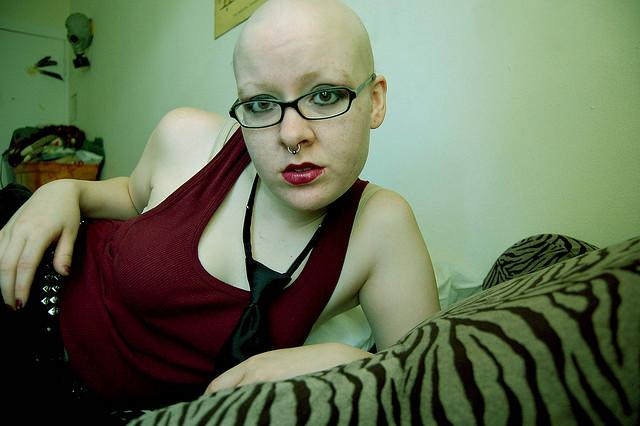What is sh doing?

Choices:
A) eating
B) posing
C) sleeping
D) resting posing 